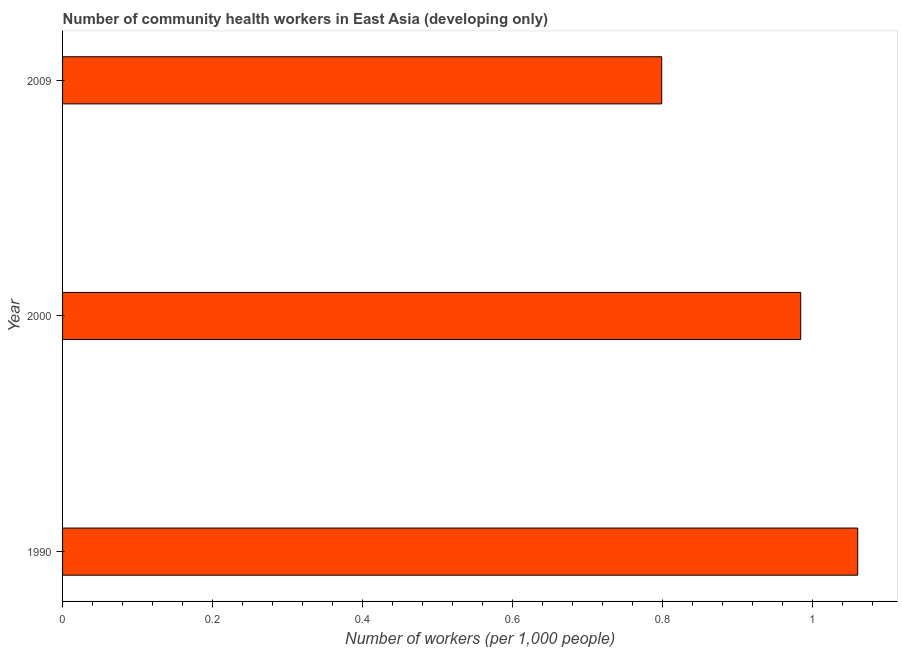What is the title of the graph?
Your answer should be compact. Number of community health workers in East Asia (developing only). What is the label or title of the X-axis?
Ensure brevity in your answer.  Number of workers (per 1,0 people). What is the label or title of the Y-axis?
Make the answer very short. Year. What is the number of community health workers in 2000?
Offer a very short reply. 0.98. Across all years, what is the maximum number of community health workers?
Your answer should be compact. 1.06. Across all years, what is the minimum number of community health workers?
Your answer should be compact. 0.8. In which year was the number of community health workers maximum?
Make the answer very short. 1990. What is the sum of the number of community health workers?
Ensure brevity in your answer.  2.84. What is the difference between the number of community health workers in 1990 and 2000?
Your response must be concise. 0.08. What is the average number of community health workers per year?
Provide a succinct answer. 0.95. What is the median number of community health workers?
Your answer should be compact. 0.98. In how many years, is the number of community health workers greater than 0.28 ?
Offer a very short reply. 3. What is the ratio of the number of community health workers in 1990 to that in 2009?
Make the answer very short. 1.33. Is the difference between the number of community health workers in 2000 and 2009 greater than the difference between any two years?
Make the answer very short. No. What is the difference between the highest and the second highest number of community health workers?
Keep it short and to the point. 0.08. What is the difference between the highest and the lowest number of community health workers?
Offer a very short reply. 0.26. In how many years, is the number of community health workers greater than the average number of community health workers taken over all years?
Give a very brief answer. 2. How many bars are there?
Keep it short and to the point. 3. Are all the bars in the graph horizontal?
Ensure brevity in your answer.  Yes. What is the difference between two consecutive major ticks on the X-axis?
Ensure brevity in your answer.  0.2. What is the Number of workers (per 1,000 people) of 1990?
Keep it short and to the point. 1.06. What is the Number of workers (per 1,000 people) in 2000?
Your answer should be very brief. 0.98. What is the Number of workers (per 1,000 people) of 2009?
Keep it short and to the point. 0.8. What is the difference between the Number of workers (per 1,000 people) in 1990 and 2000?
Your answer should be very brief. 0.08. What is the difference between the Number of workers (per 1,000 people) in 1990 and 2009?
Give a very brief answer. 0.26. What is the difference between the Number of workers (per 1,000 people) in 2000 and 2009?
Your answer should be very brief. 0.19. What is the ratio of the Number of workers (per 1,000 people) in 1990 to that in 2000?
Offer a terse response. 1.08. What is the ratio of the Number of workers (per 1,000 people) in 1990 to that in 2009?
Provide a succinct answer. 1.33. What is the ratio of the Number of workers (per 1,000 people) in 2000 to that in 2009?
Offer a very short reply. 1.23. 